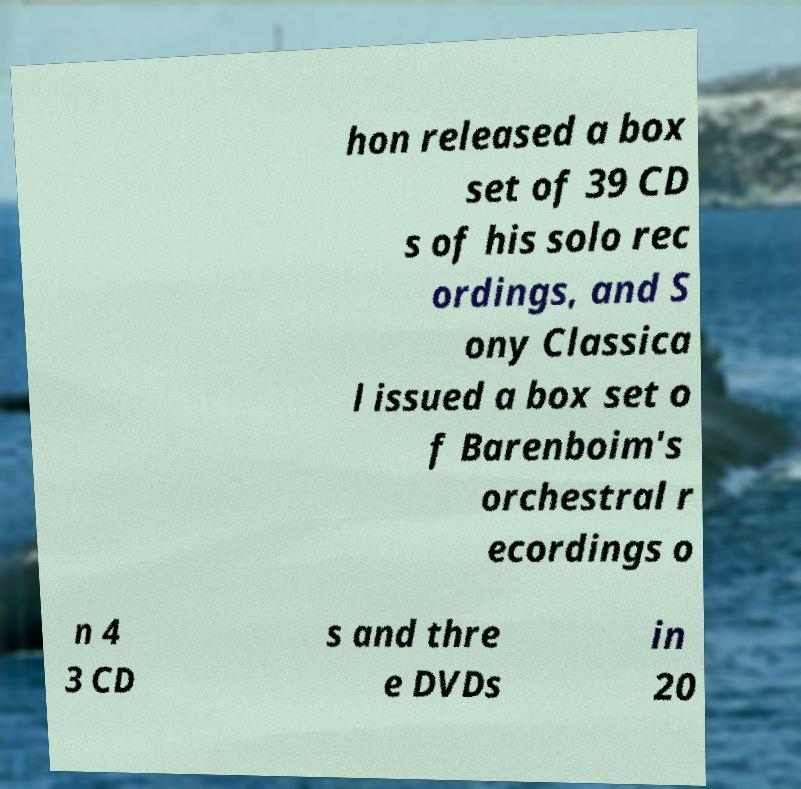There's text embedded in this image that I need extracted. Can you transcribe it verbatim? hon released a box set of 39 CD s of his solo rec ordings, and S ony Classica l issued a box set o f Barenboim's orchestral r ecordings o n 4 3 CD s and thre e DVDs in 20 